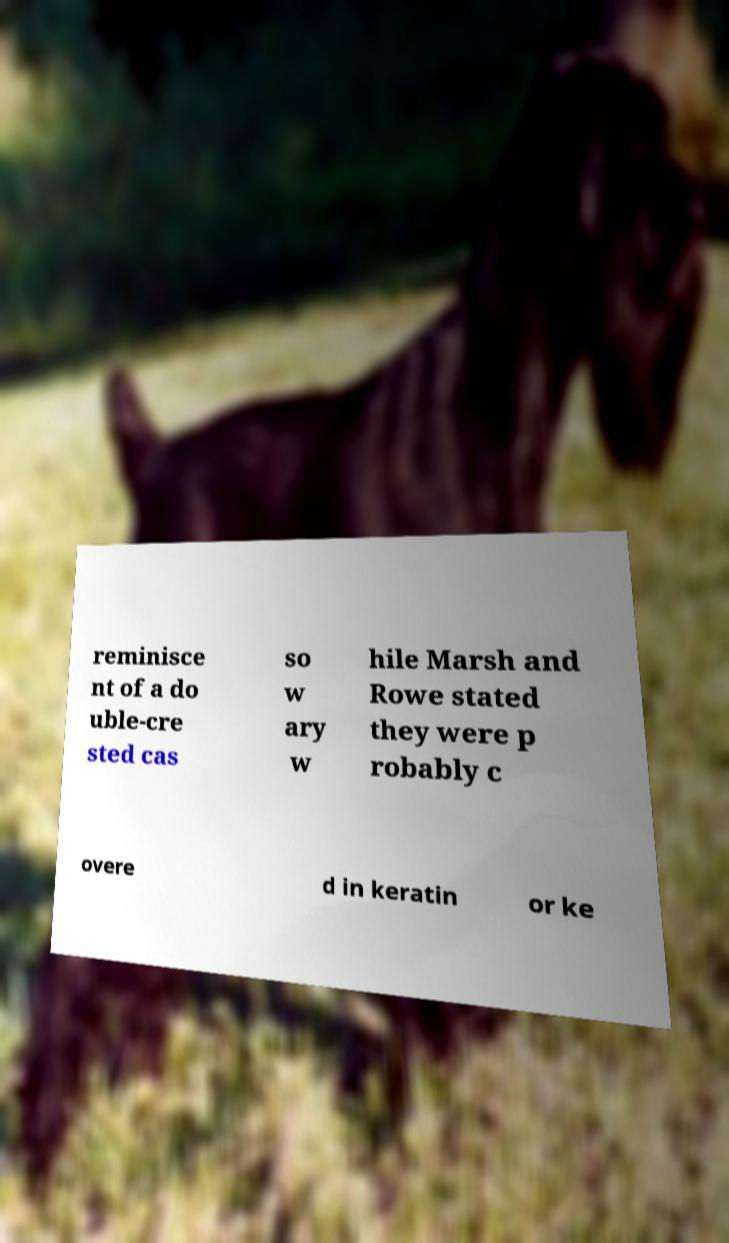Please read and relay the text visible in this image. What does it say? reminisce nt of a do uble-cre sted cas so w ary w hile Marsh and Rowe stated they were p robably c overe d in keratin or ke 